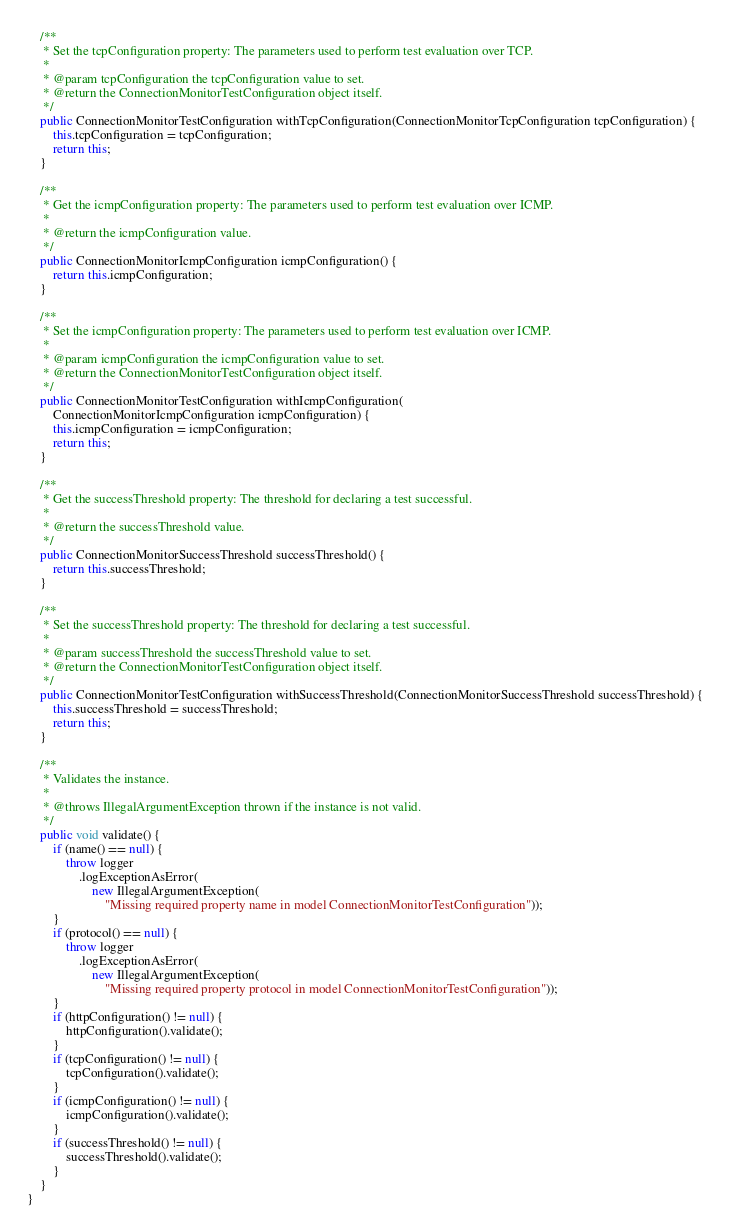Convert code to text. <code><loc_0><loc_0><loc_500><loc_500><_Java_>    /**
     * Set the tcpConfiguration property: The parameters used to perform test evaluation over TCP.
     *
     * @param tcpConfiguration the tcpConfiguration value to set.
     * @return the ConnectionMonitorTestConfiguration object itself.
     */
    public ConnectionMonitorTestConfiguration withTcpConfiguration(ConnectionMonitorTcpConfiguration tcpConfiguration) {
        this.tcpConfiguration = tcpConfiguration;
        return this;
    }

    /**
     * Get the icmpConfiguration property: The parameters used to perform test evaluation over ICMP.
     *
     * @return the icmpConfiguration value.
     */
    public ConnectionMonitorIcmpConfiguration icmpConfiguration() {
        return this.icmpConfiguration;
    }

    /**
     * Set the icmpConfiguration property: The parameters used to perform test evaluation over ICMP.
     *
     * @param icmpConfiguration the icmpConfiguration value to set.
     * @return the ConnectionMonitorTestConfiguration object itself.
     */
    public ConnectionMonitorTestConfiguration withIcmpConfiguration(
        ConnectionMonitorIcmpConfiguration icmpConfiguration) {
        this.icmpConfiguration = icmpConfiguration;
        return this;
    }

    /**
     * Get the successThreshold property: The threshold for declaring a test successful.
     *
     * @return the successThreshold value.
     */
    public ConnectionMonitorSuccessThreshold successThreshold() {
        return this.successThreshold;
    }

    /**
     * Set the successThreshold property: The threshold for declaring a test successful.
     *
     * @param successThreshold the successThreshold value to set.
     * @return the ConnectionMonitorTestConfiguration object itself.
     */
    public ConnectionMonitorTestConfiguration withSuccessThreshold(ConnectionMonitorSuccessThreshold successThreshold) {
        this.successThreshold = successThreshold;
        return this;
    }

    /**
     * Validates the instance.
     *
     * @throws IllegalArgumentException thrown if the instance is not valid.
     */
    public void validate() {
        if (name() == null) {
            throw logger
                .logExceptionAsError(
                    new IllegalArgumentException(
                        "Missing required property name in model ConnectionMonitorTestConfiguration"));
        }
        if (protocol() == null) {
            throw logger
                .logExceptionAsError(
                    new IllegalArgumentException(
                        "Missing required property protocol in model ConnectionMonitorTestConfiguration"));
        }
        if (httpConfiguration() != null) {
            httpConfiguration().validate();
        }
        if (tcpConfiguration() != null) {
            tcpConfiguration().validate();
        }
        if (icmpConfiguration() != null) {
            icmpConfiguration().validate();
        }
        if (successThreshold() != null) {
            successThreshold().validate();
        }
    }
}
</code> 